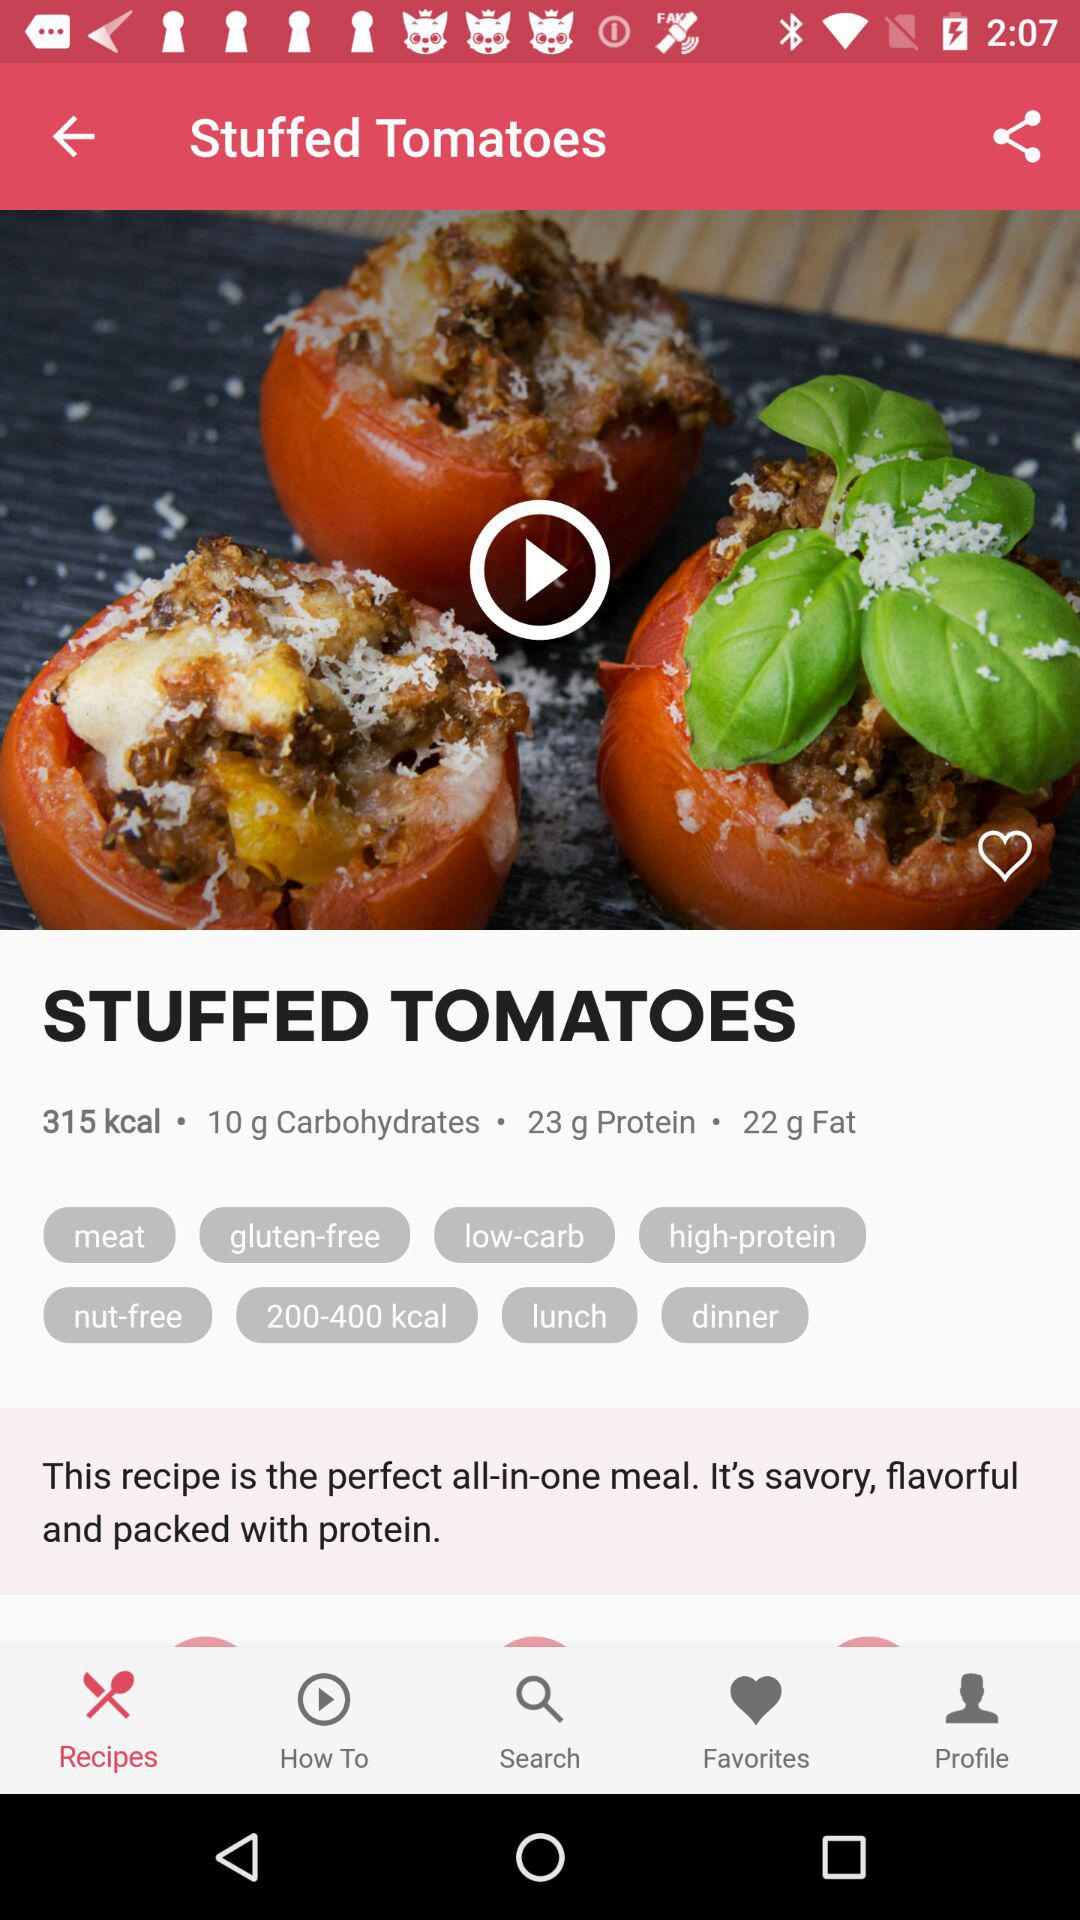How much protein is in the dish? The protein in the dish is 23 g. 